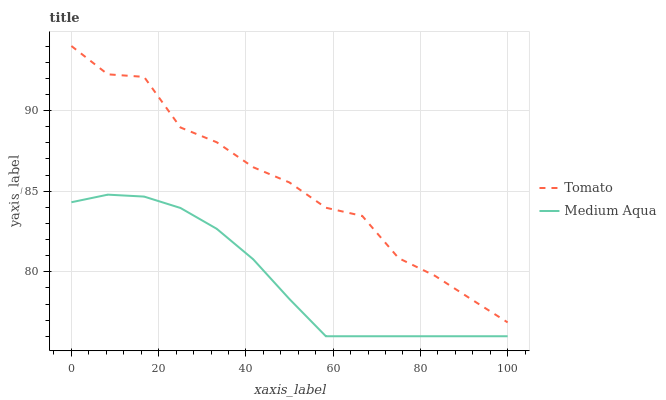Does Medium Aqua have the minimum area under the curve?
Answer yes or no. Yes. Does Tomato have the maximum area under the curve?
Answer yes or no. Yes. Does Medium Aqua have the maximum area under the curve?
Answer yes or no. No. Is Medium Aqua the smoothest?
Answer yes or no. Yes. Is Tomato the roughest?
Answer yes or no. Yes. Is Medium Aqua the roughest?
Answer yes or no. No. Does Medium Aqua have the lowest value?
Answer yes or no. Yes. Does Tomato have the highest value?
Answer yes or no. Yes. Does Medium Aqua have the highest value?
Answer yes or no. No. Is Medium Aqua less than Tomato?
Answer yes or no. Yes. Is Tomato greater than Medium Aqua?
Answer yes or no. Yes. Does Medium Aqua intersect Tomato?
Answer yes or no. No. 